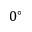Convert formula to latex. <formula><loc_0><loc_0><loc_500><loc_500>0 ^ { \circ }</formula> 